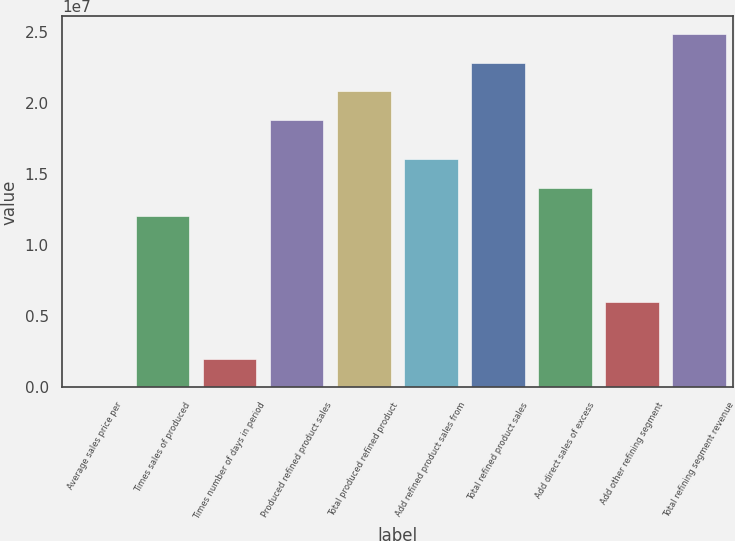Convert chart. <chart><loc_0><loc_0><loc_500><loc_500><bar_chart><fcel>Average sales price per<fcel>Times sales of produced<fcel>Times number of days in period<fcel>Produced refined product sales<fcel>Total produced refined product<fcel>Add refined product sales from<fcel>Total refined product sales<fcel>Add direct sales of excess<fcel>Add other refining segment<fcel>Total refining segment revenue<nl><fcel>119.48<fcel>1.20545e+07<fcel>2.00918e+06<fcel>1.88501e+07<fcel>2.08592e+07<fcel>1.60726e+07<fcel>2.28682e+07<fcel>1.40635e+07<fcel>6.0273e+06<fcel>2.48773e+07<nl></chart> 